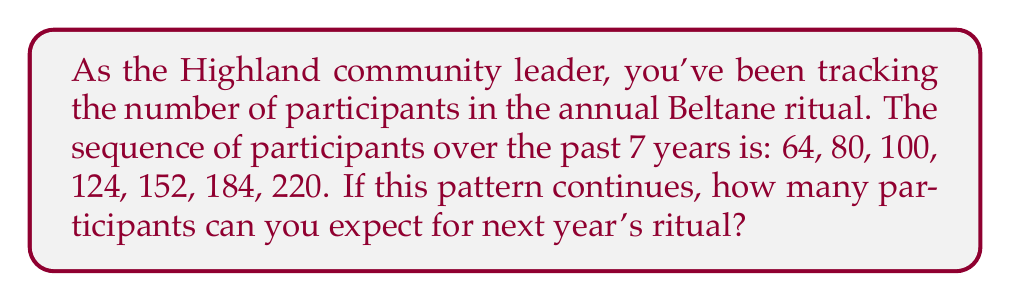Teach me how to tackle this problem. Let's analyze the pattern step-by-step:

1) First, let's calculate the differences between consecutive terms:
   80 - 64 = 16
   100 - 80 = 20
   124 - 100 = 24
   152 - 124 = 28
   184 - 152 = 32
   220 - 184 = 36

2) We can see that the differences are increasing by 4 each time:
   16, 20, 24, 28, 32, 36

3) This suggests that the sequence follows a quadratic pattern.

4) Let's express the nth term of the sequence as:
   $a_n = an^2 + bn + c$

5) We can use the first three terms to set up a system of equations:
   $64 = a(1)^2 + b(1) + c$
   $80 = a(2)^2 + b(2) + c$
   $100 = a(3)^2 + b(3) + c$

6) Solving this system (which is a bit complex to show here), we get:
   $a = 4$, $b = 8$, $c = 52$

7) So, the general term of our sequence is:
   $a_n = 4n^2 + 8n + 52$

8) To find the next term (8th year), we substitute $n = 8$:
   $a_8 = 4(8)^2 + 8(8) + 52$
   $a_8 = 4(64) + 64 + 52$
   $a_8 = 256 + 64 + 52$
   $a_8 = 372$

Therefore, based on the pattern, we can expect 372 participants for next year's ritual.
Answer: 372 